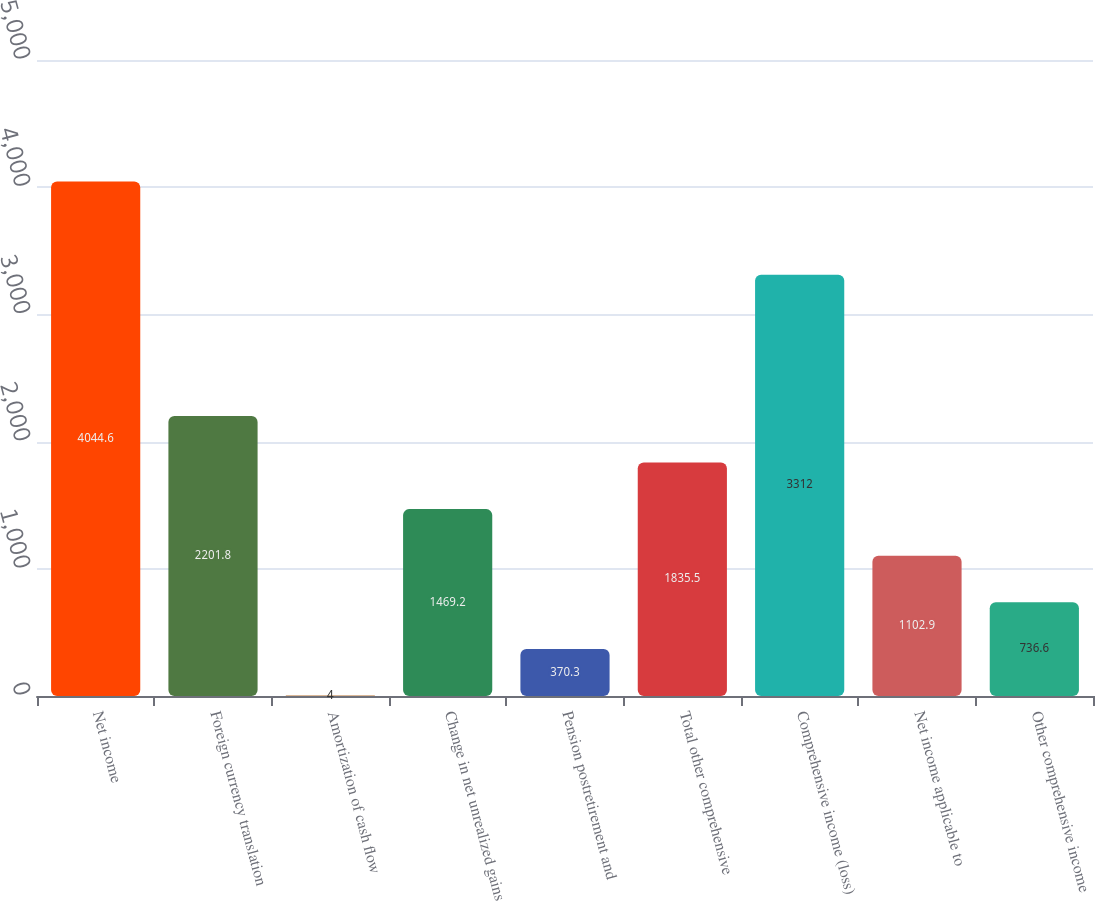Convert chart to OTSL. <chart><loc_0><loc_0><loc_500><loc_500><bar_chart><fcel>Net income<fcel>Foreign currency translation<fcel>Amortization of cash flow<fcel>Change in net unrealized gains<fcel>Pension postretirement and<fcel>Total other comprehensive<fcel>Comprehensive income (loss)<fcel>Net income applicable to<fcel>Other comprehensive income<nl><fcel>4044.6<fcel>2201.8<fcel>4<fcel>1469.2<fcel>370.3<fcel>1835.5<fcel>3312<fcel>1102.9<fcel>736.6<nl></chart> 